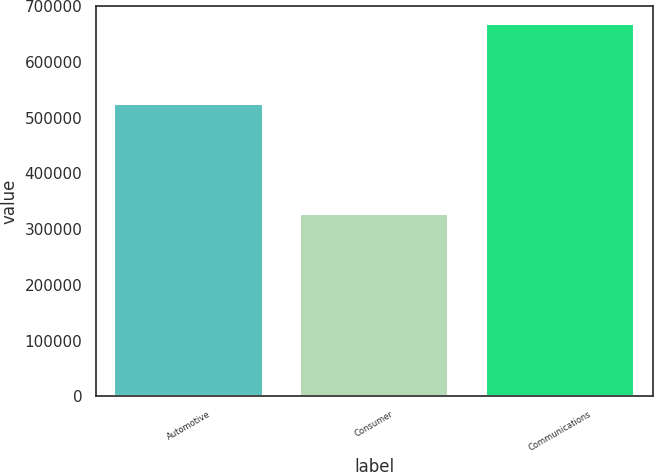Convert chart to OTSL. <chart><loc_0><loc_0><loc_500><loc_500><bar_chart><fcel>Automotive<fcel>Consumer<fcel>Communications<nl><fcel>525123<fcel>327434<fcel>667310<nl></chart> 